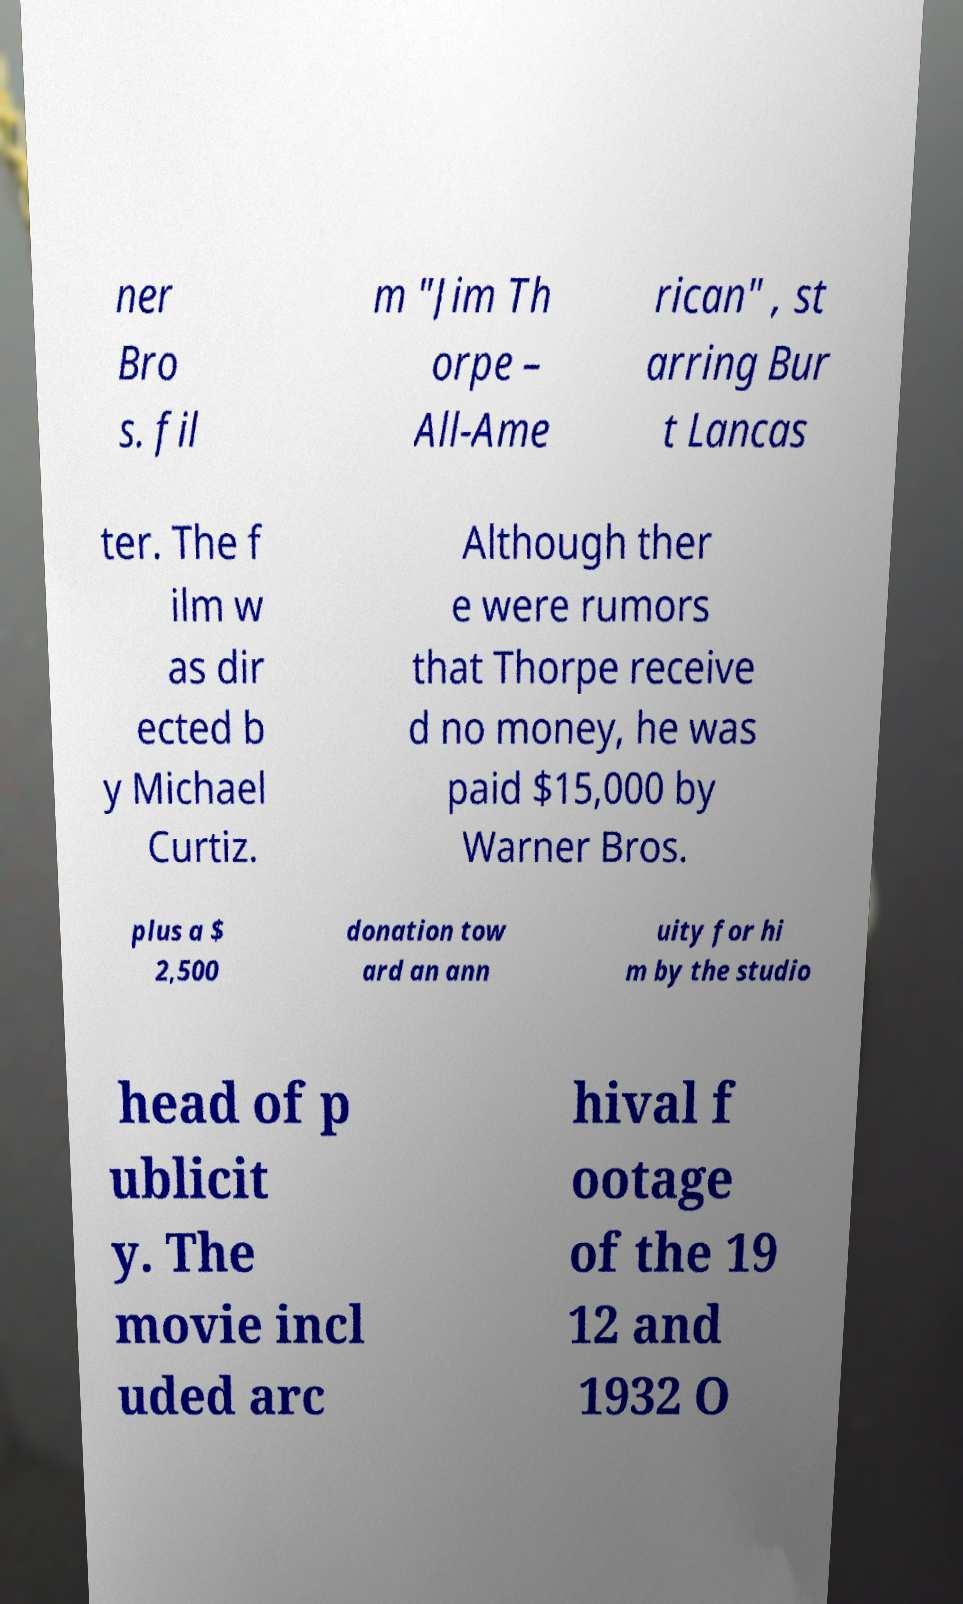I need the written content from this picture converted into text. Can you do that? ner Bro s. fil m "Jim Th orpe – All-Ame rican" , st arring Bur t Lancas ter. The f ilm w as dir ected b y Michael Curtiz. Although ther e were rumors that Thorpe receive d no money, he was paid $15,000 by Warner Bros. plus a $ 2,500 donation tow ard an ann uity for hi m by the studio head of p ublicit y. The movie incl uded arc hival f ootage of the 19 12 and 1932 O 